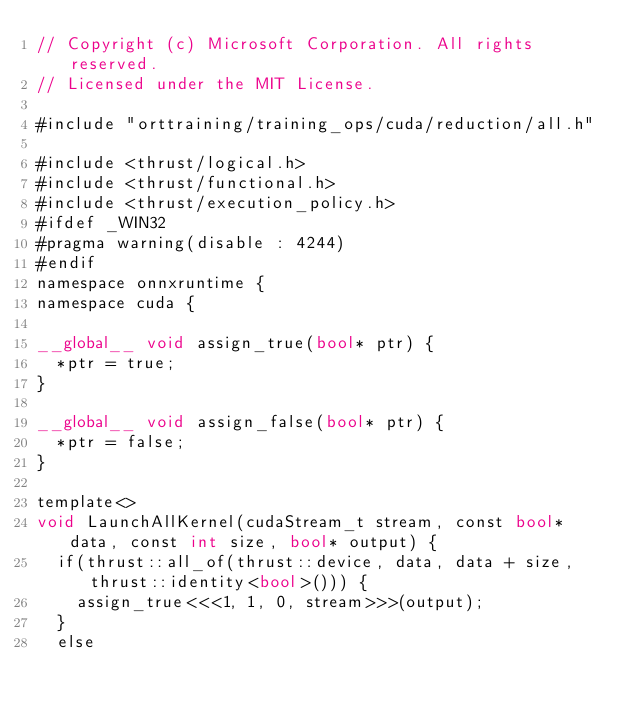Convert code to text. <code><loc_0><loc_0><loc_500><loc_500><_Cuda_>// Copyright (c) Microsoft Corporation. All rights reserved.
// Licensed under the MIT License.

#include "orttraining/training_ops/cuda/reduction/all.h"

#include <thrust/logical.h>
#include <thrust/functional.h>
#include <thrust/execution_policy.h>
#ifdef _WIN32
#pragma warning(disable : 4244)
#endif
namespace onnxruntime {
namespace cuda {

__global__ void assign_true(bool* ptr) {
  *ptr = true;
}

__global__ void assign_false(bool* ptr) {
  *ptr = false;
}

template<>
void LaunchAllKernel(cudaStream_t stream, const bool* data, const int size, bool* output) {
  if(thrust::all_of(thrust::device, data, data + size, thrust::identity<bool>())) {
    assign_true<<<1, 1, 0, stream>>>(output);
  }
  else</code> 